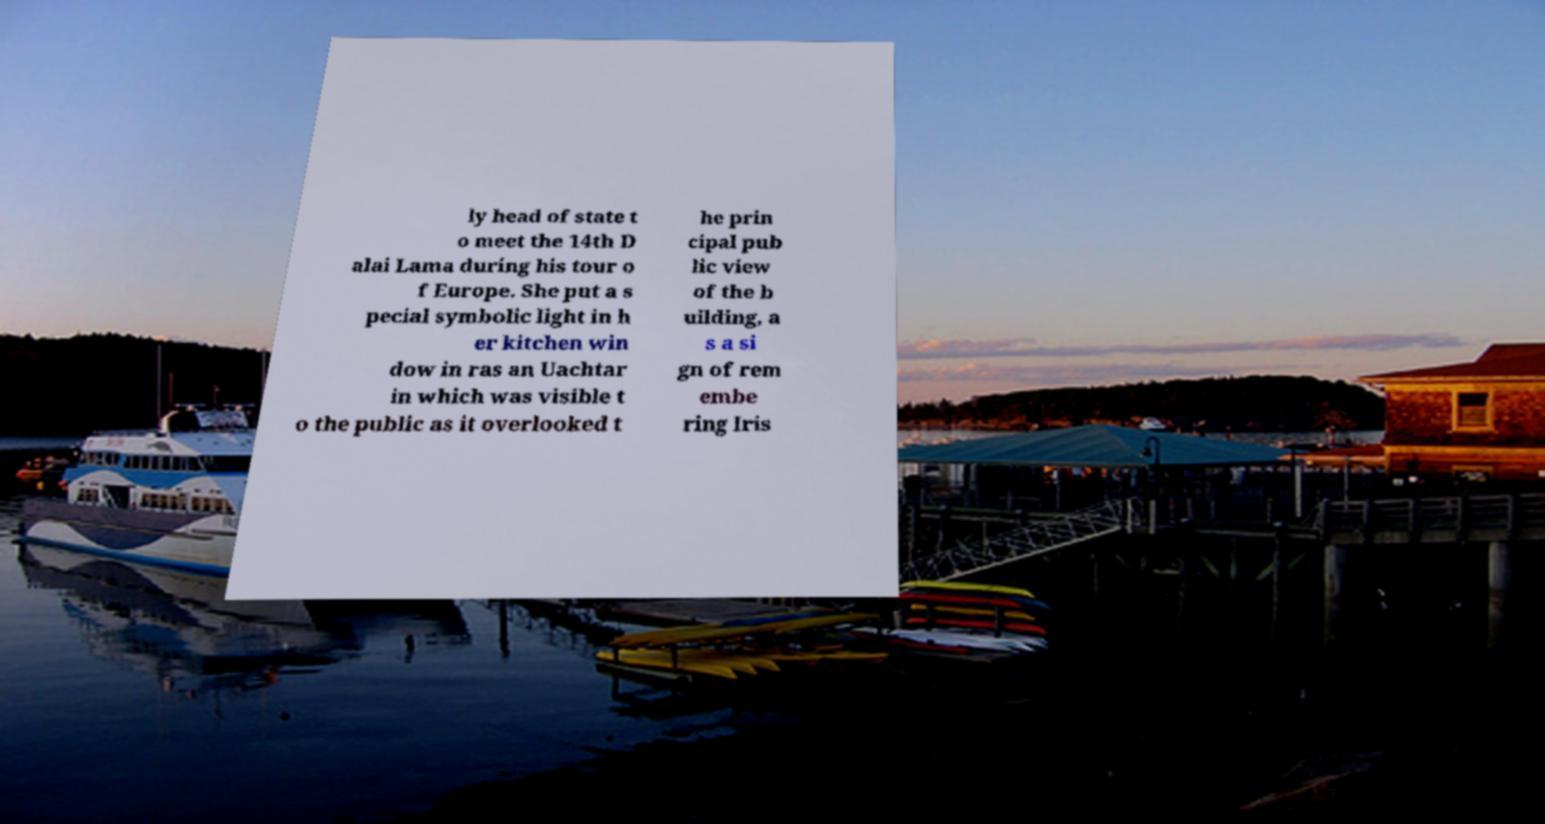Can you accurately transcribe the text from the provided image for me? ly head of state t o meet the 14th D alai Lama during his tour o f Europe. She put a s pecial symbolic light in h er kitchen win dow in ras an Uachtar in which was visible t o the public as it overlooked t he prin cipal pub lic view of the b uilding, a s a si gn of rem embe ring Iris 